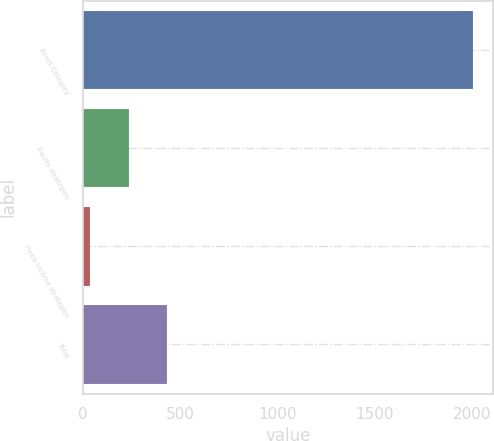<chart> <loc_0><loc_0><loc_500><loc_500><bar_chart><fcel>Asset Category<fcel>Equity strategies<fcel>Fixed income strategies<fcel>Total<nl><fcel>2006<fcel>235.7<fcel>39<fcel>432.4<nl></chart> 